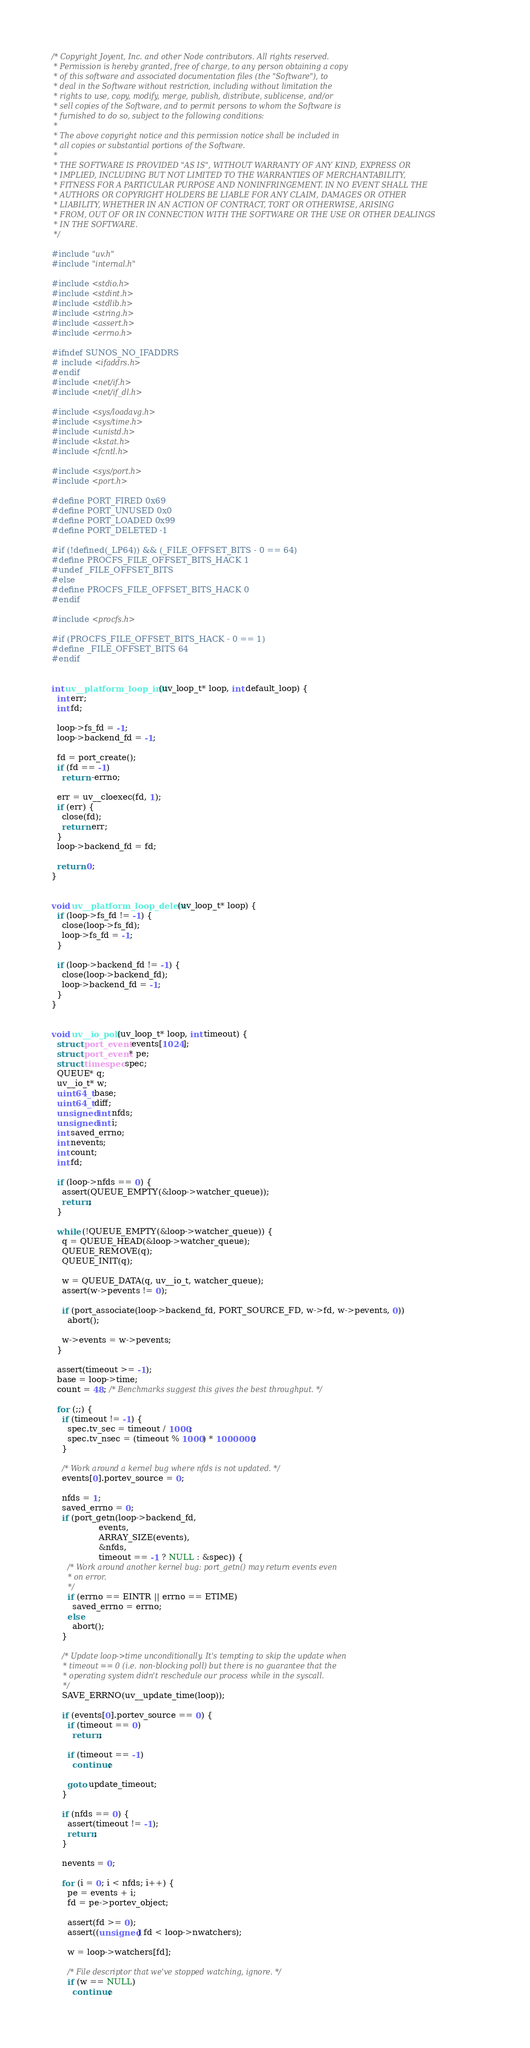<code> <loc_0><loc_0><loc_500><loc_500><_C_>/* Copyright Joyent, Inc. and other Node contributors. All rights reserved.
 * Permission is hereby granted, free of charge, to any person obtaining a copy
 * of this software and associated documentation files (the "Software"), to
 * deal in the Software without restriction, including without limitation the
 * rights to use, copy, modify, merge, publish, distribute, sublicense, and/or
 * sell copies of the Software, and to permit persons to whom the Software is
 * furnished to do so, subject to the following conditions:
 *
 * The above copyright notice and this permission notice shall be included in
 * all copies or substantial portions of the Software.
 *
 * THE SOFTWARE IS PROVIDED "AS IS", WITHOUT WARRANTY OF ANY KIND, EXPRESS OR
 * IMPLIED, INCLUDING BUT NOT LIMITED TO THE WARRANTIES OF MERCHANTABILITY,
 * FITNESS FOR A PARTICULAR PURPOSE AND NONINFRINGEMENT. IN NO EVENT SHALL THE
 * AUTHORS OR COPYRIGHT HOLDERS BE LIABLE FOR ANY CLAIM, DAMAGES OR OTHER
 * LIABILITY, WHETHER IN AN ACTION OF CONTRACT, TORT OR OTHERWISE, ARISING
 * FROM, OUT OF OR IN CONNECTION WITH THE SOFTWARE OR THE USE OR OTHER DEALINGS
 * IN THE SOFTWARE.
 */

#include "uv.h"
#include "internal.h"

#include <stdio.h>
#include <stdint.h>
#include <stdlib.h>
#include <string.h>
#include <assert.h>
#include <errno.h>

#ifndef SUNOS_NO_IFADDRS
# include <ifaddrs.h>
#endif
#include <net/if.h>
#include <net/if_dl.h>

#include <sys/loadavg.h>
#include <sys/time.h>
#include <unistd.h>
#include <kstat.h>
#include <fcntl.h>

#include <sys/port.h>
#include <port.h>

#define PORT_FIRED 0x69
#define PORT_UNUSED 0x0
#define PORT_LOADED 0x99
#define PORT_DELETED -1

#if (!defined(_LP64)) && (_FILE_OFFSET_BITS - 0 == 64)
#define PROCFS_FILE_OFFSET_BITS_HACK 1
#undef _FILE_OFFSET_BITS
#else
#define PROCFS_FILE_OFFSET_BITS_HACK 0
#endif

#include <procfs.h>

#if (PROCFS_FILE_OFFSET_BITS_HACK - 0 == 1)
#define _FILE_OFFSET_BITS 64
#endif


int uv__platform_loop_init(uv_loop_t* loop, int default_loop) {
  int err;
  int fd;

  loop->fs_fd = -1;
  loop->backend_fd = -1;

  fd = port_create();
  if (fd == -1)
    return -errno;

  err = uv__cloexec(fd, 1);
  if (err) {
    close(fd);
    return err;
  }
  loop->backend_fd = fd;

  return 0;
}


void uv__platform_loop_delete(uv_loop_t* loop) {
  if (loop->fs_fd != -1) {
    close(loop->fs_fd);
    loop->fs_fd = -1;
  }

  if (loop->backend_fd != -1) {
    close(loop->backend_fd);
    loop->backend_fd = -1;
  }
}


void uv__io_poll(uv_loop_t* loop, int timeout) {
  struct port_event events[1024];
  struct port_event* pe;
  struct timespec spec;
  QUEUE* q;
  uv__io_t* w;
  uint64_t base;
  uint64_t diff;
  unsigned int nfds;
  unsigned int i;
  int saved_errno;
  int nevents;
  int count;
  int fd;

  if (loop->nfds == 0) {
    assert(QUEUE_EMPTY(&loop->watcher_queue));
    return;
  }

  while (!QUEUE_EMPTY(&loop->watcher_queue)) {
    q = QUEUE_HEAD(&loop->watcher_queue);
    QUEUE_REMOVE(q);
    QUEUE_INIT(q);

    w = QUEUE_DATA(q, uv__io_t, watcher_queue);
    assert(w->pevents != 0);

    if (port_associate(loop->backend_fd, PORT_SOURCE_FD, w->fd, w->pevents, 0))
      abort();

    w->events = w->pevents;
  }

  assert(timeout >= -1);
  base = loop->time;
  count = 48; /* Benchmarks suggest this gives the best throughput. */

  for (;;) {
    if (timeout != -1) {
      spec.tv_sec = timeout / 1000;
      spec.tv_nsec = (timeout % 1000) * 1000000;
    }

    /* Work around a kernel bug where nfds is not updated. */
    events[0].portev_source = 0;

    nfds = 1;
    saved_errno = 0;
    if (port_getn(loop->backend_fd,
                  events,
                  ARRAY_SIZE(events),
                  &nfds,
                  timeout == -1 ? NULL : &spec)) {
      /* Work around another kernel bug: port_getn() may return events even
       * on error.
       */
      if (errno == EINTR || errno == ETIME)
        saved_errno = errno;
      else
        abort();
    }

    /* Update loop->time unconditionally. It's tempting to skip the update when
     * timeout == 0 (i.e. non-blocking poll) but there is no guarantee that the
     * operating system didn't reschedule our process while in the syscall.
     */
    SAVE_ERRNO(uv__update_time(loop));

    if (events[0].portev_source == 0) {
      if (timeout == 0)
        return;

      if (timeout == -1)
        continue;

      goto update_timeout;
    }

    if (nfds == 0) {
      assert(timeout != -1);
      return;
    }

    nevents = 0;

    for (i = 0; i < nfds; i++) {
      pe = events + i;
      fd = pe->portev_object;

      assert(fd >= 0);
      assert((unsigned) fd < loop->nwatchers);

      w = loop->watchers[fd];

      /* File descriptor that we've stopped watching, ignore. */
      if (w == NULL)
        continue;
</code> 